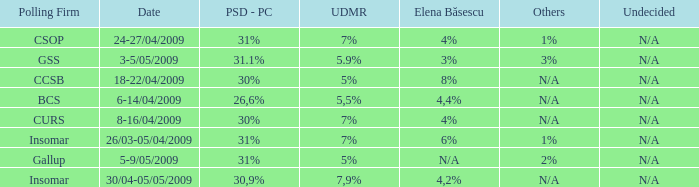Can you give me this table as a dict? {'header': ['Polling Firm', 'Date', 'PSD - PC', 'UDMR', 'Elena Băsescu', 'Others', 'Undecided'], 'rows': [['CSOP', '24-27/04/2009', '31%', '7%', '4%', '1%', 'N/A'], ['GSS', '3-5/05/2009', '31.1%', '5.9%', '3%', '3%', 'N/A'], ['CCSB', '18-22/04/2009', '30%', '5%', '8%', 'N/A', 'N/A'], ['BCS', '6-14/04/2009', '26,6%', '5,5%', '4,4%', 'N/A', 'N/A'], ['CURS', '8-16/04/2009', '30%', '7%', '4%', 'N/A', 'N/A'], ['Insomar', '26/03-05/04/2009', '31%', '7%', '6%', '1%', 'N/A'], ['Gallup', '5-9/05/2009', '31%', '5%', 'N/A', '2%', 'N/A'], ['Insomar', '30/04-05/05/2009', '30,9%', '7,9%', '4,2%', 'N/A', 'N/A']]} When the other is n/a and the psc-pc is 30% what is the date? 8-16/04/2009, 18-22/04/2009. 